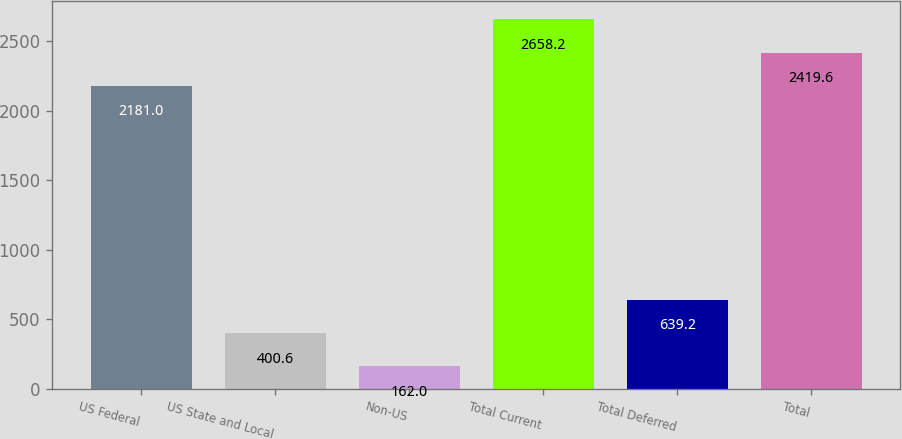Convert chart to OTSL. <chart><loc_0><loc_0><loc_500><loc_500><bar_chart><fcel>US Federal<fcel>US State and Local<fcel>Non-US<fcel>Total Current<fcel>Total Deferred<fcel>Total<nl><fcel>2181<fcel>400.6<fcel>162<fcel>2658.2<fcel>639.2<fcel>2419.6<nl></chart> 